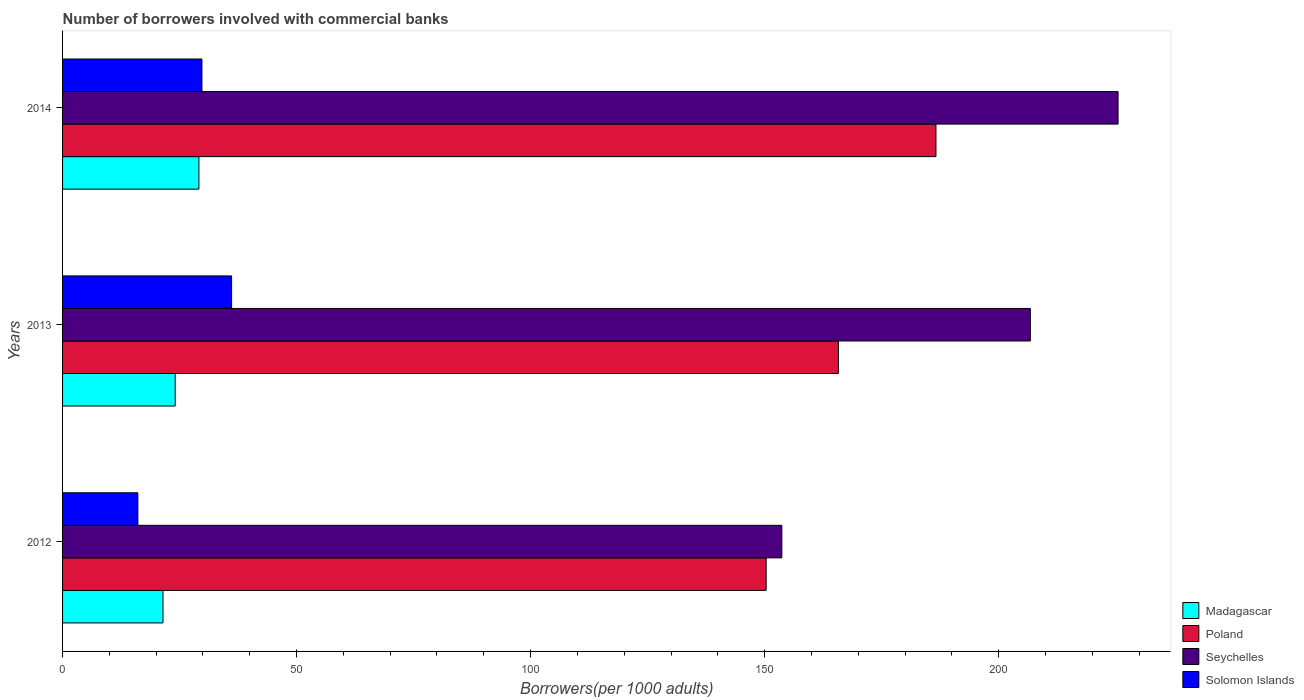Are the number of bars per tick equal to the number of legend labels?
Your answer should be very brief. Yes. Are the number of bars on each tick of the Y-axis equal?
Give a very brief answer. Yes. How many bars are there on the 2nd tick from the top?
Provide a short and direct response. 4. How many bars are there on the 2nd tick from the bottom?
Provide a short and direct response. 4. What is the label of the 3rd group of bars from the top?
Your answer should be compact. 2012. In how many cases, is the number of bars for a given year not equal to the number of legend labels?
Your answer should be compact. 0. What is the number of borrowers involved with commercial banks in Madagascar in 2013?
Make the answer very short. 24.07. Across all years, what is the maximum number of borrowers involved with commercial banks in Madagascar?
Give a very brief answer. 29.13. Across all years, what is the minimum number of borrowers involved with commercial banks in Poland?
Make the answer very short. 150.33. What is the total number of borrowers involved with commercial banks in Solomon Islands in the graph?
Provide a short and direct response. 81.98. What is the difference between the number of borrowers involved with commercial banks in Seychelles in 2013 and that in 2014?
Make the answer very short. -18.74. What is the difference between the number of borrowers involved with commercial banks in Madagascar in 2013 and the number of borrowers involved with commercial banks in Poland in 2012?
Make the answer very short. -126.27. What is the average number of borrowers involved with commercial banks in Madagascar per year?
Your answer should be compact. 24.89. In the year 2014, what is the difference between the number of borrowers involved with commercial banks in Solomon Islands and number of borrowers involved with commercial banks in Seychelles?
Provide a short and direct response. -195.74. In how many years, is the number of borrowers involved with commercial banks in Poland greater than 140 ?
Offer a terse response. 3. What is the ratio of the number of borrowers involved with commercial banks in Poland in 2013 to that in 2014?
Offer a terse response. 0.89. Is the number of borrowers involved with commercial banks in Seychelles in 2013 less than that in 2014?
Give a very brief answer. Yes. Is the difference between the number of borrowers involved with commercial banks in Solomon Islands in 2013 and 2014 greater than the difference between the number of borrowers involved with commercial banks in Seychelles in 2013 and 2014?
Your response must be concise. Yes. What is the difference between the highest and the second highest number of borrowers involved with commercial banks in Poland?
Your answer should be very brief. 20.85. What is the difference between the highest and the lowest number of borrowers involved with commercial banks in Seychelles?
Keep it short and to the point. 71.84. In how many years, is the number of borrowers involved with commercial banks in Solomon Islands greater than the average number of borrowers involved with commercial banks in Solomon Islands taken over all years?
Provide a succinct answer. 2. Is it the case that in every year, the sum of the number of borrowers involved with commercial banks in Solomon Islands and number of borrowers involved with commercial banks in Poland is greater than the sum of number of borrowers involved with commercial banks in Madagascar and number of borrowers involved with commercial banks in Seychelles?
Provide a short and direct response. No. What does the 2nd bar from the top in 2013 represents?
Your answer should be very brief. Seychelles. What does the 1st bar from the bottom in 2012 represents?
Provide a succinct answer. Madagascar. Is it the case that in every year, the sum of the number of borrowers involved with commercial banks in Poland and number of borrowers involved with commercial banks in Seychelles is greater than the number of borrowers involved with commercial banks in Madagascar?
Provide a succinct answer. Yes. How many legend labels are there?
Your answer should be compact. 4. How are the legend labels stacked?
Your response must be concise. Vertical. What is the title of the graph?
Give a very brief answer. Number of borrowers involved with commercial banks. What is the label or title of the X-axis?
Provide a short and direct response. Borrowers(per 1000 adults). What is the label or title of the Y-axis?
Give a very brief answer. Years. What is the Borrowers(per 1000 adults) of Madagascar in 2012?
Your answer should be very brief. 21.46. What is the Borrowers(per 1000 adults) of Poland in 2012?
Your answer should be compact. 150.33. What is the Borrowers(per 1000 adults) of Seychelles in 2012?
Ensure brevity in your answer.  153.68. What is the Borrowers(per 1000 adults) of Solomon Islands in 2012?
Offer a very short reply. 16.09. What is the Borrowers(per 1000 adults) of Madagascar in 2013?
Your response must be concise. 24.07. What is the Borrowers(per 1000 adults) in Poland in 2013?
Your answer should be compact. 165.76. What is the Borrowers(per 1000 adults) in Seychelles in 2013?
Give a very brief answer. 206.78. What is the Borrowers(per 1000 adults) in Solomon Islands in 2013?
Ensure brevity in your answer.  36.11. What is the Borrowers(per 1000 adults) of Madagascar in 2014?
Offer a terse response. 29.13. What is the Borrowers(per 1000 adults) of Poland in 2014?
Your answer should be very brief. 186.61. What is the Borrowers(per 1000 adults) in Seychelles in 2014?
Give a very brief answer. 225.52. What is the Borrowers(per 1000 adults) of Solomon Islands in 2014?
Keep it short and to the point. 29.78. Across all years, what is the maximum Borrowers(per 1000 adults) of Madagascar?
Your answer should be very brief. 29.13. Across all years, what is the maximum Borrowers(per 1000 adults) of Poland?
Your answer should be compact. 186.61. Across all years, what is the maximum Borrowers(per 1000 adults) in Seychelles?
Make the answer very short. 225.52. Across all years, what is the maximum Borrowers(per 1000 adults) of Solomon Islands?
Offer a terse response. 36.11. Across all years, what is the minimum Borrowers(per 1000 adults) of Madagascar?
Your answer should be compact. 21.46. Across all years, what is the minimum Borrowers(per 1000 adults) of Poland?
Give a very brief answer. 150.33. Across all years, what is the minimum Borrowers(per 1000 adults) of Seychelles?
Your answer should be very brief. 153.68. Across all years, what is the minimum Borrowers(per 1000 adults) of Solomon Islands?
Offer a very short reply. 16.09. What is the total Borrowers(per 1000 adults) of Madagascar in the graph?
Make the answer very short. 74.66. What is the total Borrowers(per 1000 adults) in Poland in the graph?
Keep it short and to the point. 502.71. What is the total Borrowers(per 1000 adults) in Seychelles in the graph?
Your response must be concise. 585.98. What is the total Borrowers(per 1000 adults) of Solomon Islands in the graph?
Provide a short and direct response. 81.98. What is the difference between the Borrowers(per 1000 adults) of Madagascar in 2012 and that in 2013?
Ensure brevity in your answer.  -2.61. What is the difference between the Borrowers(per 1000 adults) of Poland in 2012 and that in 2013?
Your answer should be compact. -15.43. What is the difference between the Borrowers(per 1000 adults) in Seychelles in 2012 and that in 2013?
Your answer should be compact. -53.1. What is the difference between the Borrowers(per 1000 adults) in Solomon Islands in 2012 and that in 2013?
Make the answer very short. -20.03. What is the difference between the Borrowers(per 1000 adults) of Madagascar in 2012 and that in 2014?
Provide a succinct answer. -7.68. What is the difference between the Borrowers(per 1000 adults) in Poland in 2012 and that in 2014?
Keep it short and to the point. -36.28. What is the difference between the Borrowers(per 1000 adults) of Seychelles in 2012 and that in 2014?
Offer a terse response. -71.84. What is the difference between the Borrowers(per 1000 adults) in Solomon Islands in 2012 and that in 2014?
Your answer should be compact. -13.69. What is the difference between the Borrowers(per 1000 adults) in Madagascar in 2013 and that in 2014?
Provide a succinct answer. -5.07. What is the difference between the Borrowers(per 1000 adults) of Poland in 2013 and that in 2014?
Provide a short and direct response. -20.85. What is the difference between the Borrowers(per 1000 adults) in Seychelles in 2013 and that in 2014?
Your response must be concise. -18.74. What is the difference between the Borrowers(per 1000 adults) in Solomon Islands in 2013 and that in 2014?
Offer a terse response. 6.33. What is the difference between the Borrowers(per 1000 adults) in Madagascar in 2012 and the Borrowers(per 1000 adults) in Poland in 2013?
Your answer should be very brief. -144.3. What is the difference between the Borrowers(per 1000 adults) of Madagascar in 2012 and the Borrowers(per 1000 adults) of Seychelles in 2013?
Your response must be concise. -185.32. What is the difference between the Borrowers(per 1000 adults) in Madagascar in 2012 and the Borrowers(per 1000 adults) in Solomon Islands in 2013?
Make the answer very short. -14.66. What is the difference between the Borrowers(per 1000 adults) of Poland in 2012 and the Borrowers(per 1000 adults) of Seychelles in 2013?
Provide a succinct answer. -56.45. What is the difference between the Borrowers(per 1000 adults) of Poland in 2012 and the Borrowers(per 1000 adults) of Solomon Islands in 2013?
Keep it short and to the point. 114.22. What is the difference between the Borrowers(per 1000 adults) in Seychelles in 2012 and the Borrowers(per 1000 adults) in Solomon Islands in 2013?
Offer a very short reply. 117.57. What is the difference between the Borrowers(per 1000 adults) of Madagascar in 2012 and the Borrowers(per 1000 adults) of Poland in 2014?
Keep it short and to the point. -165.16. What is the difference between the Borrowers(per 1000 adults) of Madagascar in 2012 and the Borrowers(per 1000 adults) of Seychelles in 2014?
Provide a succinct answer. -204.06. What is the difference between the Borrowers(per 1000 adults) of Madagascar in 2012 and the Borrowers(per 1000 adults) of Solomon Islands in 2014?
Give a very brief answer. -8.32. What is the difference between the Borrowers(per 1000 adults) in Poland in 2012 and the Borrowers(per 1000 adults) in Seychelles in 2014?
Provide a short and direct response. -75.19. What is the difference between the Borrowers(per 1000 adults) of Poland in 2012 and the Borrowers(per 1000 adults) of Solomon Islands in 2014?
Offer a very short reply. 120.55. What is the difference between the Borrowers(per 1000 adults) of Seychelles in 2012 and the Borrowers(per 1000 adults) of Solomon Islands in 2014?
Provide a succinct answer. 123.9. What is the difference between the Borrowers(per 1000 adults) of Madagascar in 2013 and the Borrowers(per 1000 adults) of Poland in 2014?
Ensure brevity in your answer.  -162.55. What is the difference between the Borrowers(per 1000 adults) of Madagascar in 2013 and the Borrowers(per 1000 adults) of Seychelles in 2014?
Provide a succinct answer. -201.45. What is the difference between the Borrowers(per 1000 adults) in Madagascar in 2013 and the Borrowers(per 1000 adults) in Solomon Islands in 2014?
Make the answer very short. -5.71. What is the difference between the Borrowers(per 1000 adults) in Poland in 2013 and the Borrowers(per 1000 adults) in Seychelles in 2014?
Offer a very short reply. -59.76. What is the difference between the Borrowers(per 1000 adults) in Poland in 2013 and the Borrowers(per 1000 adults) in Solomon Islands in 2014?
Ensure brevity in your answer.  135.98. What is the difference between the Borrowers(per 1000 adults) in Seychelles in 2013 and the Borrowers(per 1000 adults) in Solomon Islands in 2014?
Provide a short and direct response. 177. What is the average Borrowers(per 1000 adults) in Madagascar per year?
Offer a very short reply. 24.89. What is the average Borrowers(per 1000 adults) in Poland per year?
Your answer should be compact. 167.57. What is the average Borrowers(per 1000 adults) of Seychelles per year?
Your response must be concise. 195.33. What is the average Borrowers(per 1000 adults) in Solomon Islands per year?
Provide a succinct answer. 27.33. In the year 2012, what is the difference between the Borrowers(per 1000 adults) in Madagascar and Borrowers(per 1000 adults) in Poland?
Your answer should be very brief. -128.87. In the year 2012, what is the difference between the Borrowers(per 1000 adults) of Madagascar and Borrowers(per 1000 adults) of Seychelles?
Your answer should be compact. -132.22. In the year 2012, what is the difference between the Borrowers(per 1000 adults) of Madagascar and Borrowers(per 1000 adults) of Solomon Islands?
Keep it short and to the point. 5.37. In the year 2012, what is the difference between the Borrowers(per 1000 adults) of Poland and Borrowers(per 1000 adults) of Seychelles?
Your response must be concise. -3.35. In the year 2012, what is the difference between the Borrowers(per 1000 adults) of Poland and Borrowers(per 1000 adults) of Solomon Islands?
Your response must be concise. 134.25. In the year 2012, what is the difference between the Borrowers(per 1000 adults) of Seychelles and Borrowers(per 1000 adults) of Solomon Islands?
Keep it short and to the point. 137.59. In the year 2013, what is the difference between the Borrowers(per 1000 adults) of Madagascar and Borrowers(per 1000 adults) of Poland?
Keep it short and to the point. -141.7. In the year 2013, what is the difference between the Borrowers(per 1000 adults) of Madagascar and Borrowers(per 1000 adults) of Seychelles?
Give a very brief answer. -182.71. In the year 2013, what is the difference between the Borrowers(per 1000 adults) in Madagascar and Borrowers(per 1000 adults) in Solomon Islands?
Keep it short and to the point. -12.05. In the year 2013, what is the difference between the Borrowers(per 1000 adults) of Poland and Borrowers(per 1000 adults) of Seychelles?
Your answer should be very brief. -41.02. In the year 2013, what is the difference between the Borrowers(per 1000 adults) of Poland and Borrowers(per 1000 adults) of Solomon Islands?
Your response must be concise. 129.65. In the year 2013, what is the difference between the Borrowers(per 1000 adults) of Seychelles and Borrowers(per 1000 adults) of Solomon Islands?
Keep it short and to the point. 170.66. In the year 2014, what is the difference between the Borrowers(per 1000 adults) in Madagascar and Borrowers(per 1000 adults) in Poland?
Offer a terse response. -157.48. In the year 2014, what is the difference between the Borrowers(per 1000 adults) of Madagascar and Borrowers(per 1000 adults) of Seychelles?
Offer a terse response. -196.39. In the year 2014, what is the difference between the Borrowers(per 1000 adults) in Madagascar and Borrowers(per 1000 adults) in Solomon Islands?
Keep it short and to the point. -0.65. In the year 2014, what is the difference between the Borrowers(per 1000 adults) in Poland and Borrowers(per 1000 adults) in Seychelles?
Keep it short and to the point. -38.91. In the year 2014, what is the difference between the Borrowers(per 1000 adults) in Poland and Borrowers(per 1000 adults) in Solomon Islands?
Ensure brevity in your answer.  156.83. In the year 2014, what is the difference between the Borrowers(per 1000 adults) of Seychelles and Borrowers(per 1000 adults) of Solomon Islands?
Keep it short and to the point. 195.74. What is the ratio of the Borrowers(per 1000 adults) of Madagascar in 2012 to that in 2013?
Your answer should be compact. 0.89. What is the ratio of the Borrowers(per 1000 adults) of Poland in 2012 to that in 2013?
Offer a very short reply. 0.91. What is the ratio of the Borrowers(per 1000 adults) of Seychelles in 2012 to that in 2013?
Offer a terse response. 0.74. What is the ratio of the Borrowers(per 1000 adults) of Solomon Islands in 2012 to that in 2013?
Ensure brevity in your answer.  0.45. What is the ratio of the Borrowers(per 1000 adults) in Madagascar in 2012 to that in 2014?
Your response must be concise. 0.74. What is the ratio of the Borrowers(per 1000 adults) in Poland in 2012 to that in 2014?
Your answer should be very brief. 0.81. What is the ratio of the Borrowers(per 1000 adults) of Seychelles in 2012 to that in 2014?
Provide a short and direct response. 0.68. What is the ratio of the Borrowers(per 1000 adults) in Solomon Islands in 2012 to that in 2014?
Offer a terse response. 0.54. What is the ratio of the Borrowers(per 1000 adults) in Madagascar in 2013 to that in 2014?
Provide a short and direct response. 0.83. What is the ratio of the Borrowers(per 1000 adults) of Poland in 2013 to that in 2014?
Give a very brief answer. 0.89. What is the ratio of the Borrowers(per 1000 adults) of Seychelles in 2013 to that in 2014?
Your answer should be compact. 0.92. What is the ratio of the Borrowers(per 1000 adults) in Solomon Islands in 2013 to that in 2014?
Provide a short and direct response. 1.21. What is the difference between the highest and the second highest Borrowers(per 1000 adults) in Madagascar?
Your answer should be very brief. 5.07. What is the difference between the highest and the second highest Borrowers(per 1000 adults) of Poland?
Your answer should be very brief. 20.85. What is the difference between the highest and the second highest Borrowers(per 1000 adults) of Seychelles?
Your answer should be very brief. 18.74. What is the difference between the highest and the second highest Borrowers(per 1000 adults) in Solomon Islands?
Make the answer very short. 6.33. What is the difference between the highest and the lowest Borrowers(per 1000 adults) in Madagascar?
Your answer should be compact. 7.68. What is the difference between the highest and the lowest Borrowers(per 1000 adults) in Poland?
Offer a very short reply. 36.28. What is the difference between the highest and the lowest Borrowers(per 1000 adults) in Seychelles?
Offer a very short reply. 71.84. What is the difference between the highest and the lowest Borrowers(per 1000 adults) in Solomon Islands?
Provide a short and direct response. 20.03. 